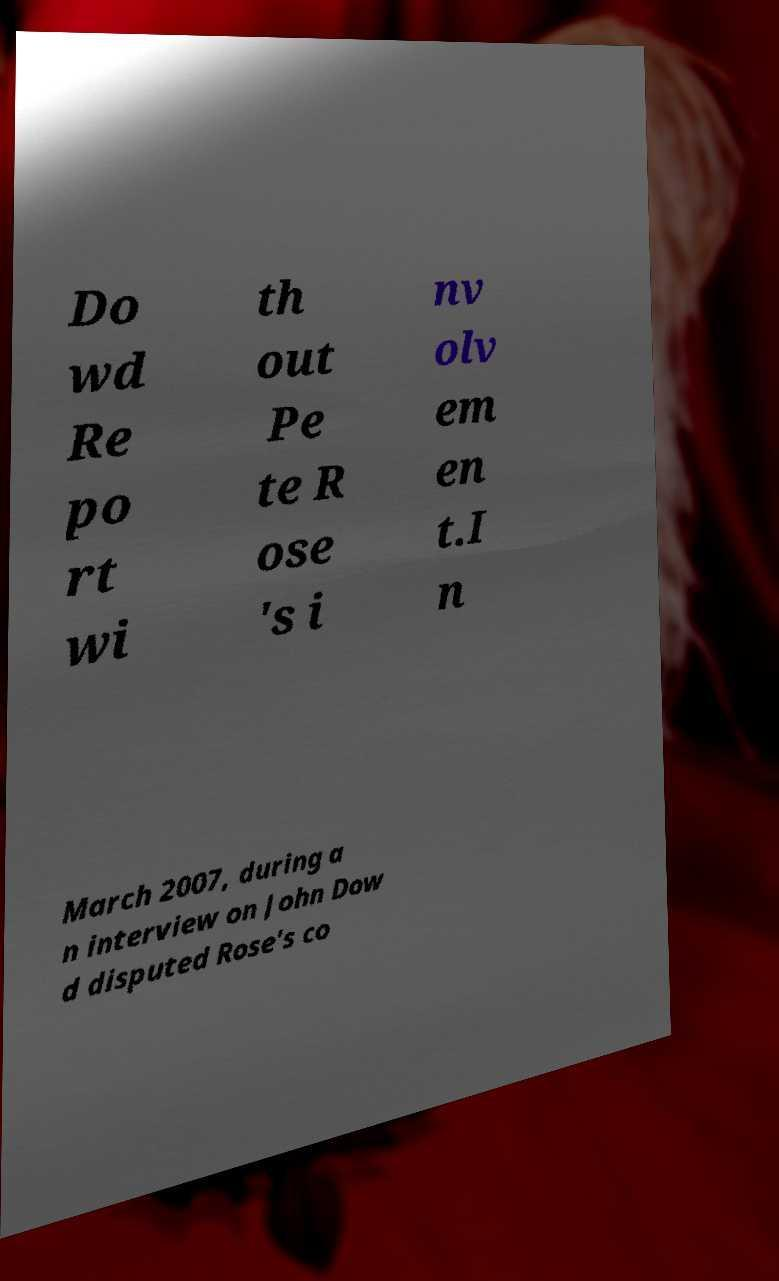Can you read and provide the text displayed in the image?This photo seems to have some interesting text. Can you extract and type it out for me? Do wd Re po rt wi th out Pe te R ose 's i nv olv em en t.I n March 2007, during a n interview on John Dow d disputed Rose's co 